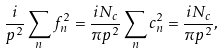<formula> <loc_0><loc_0><loc_500><loc_500>\frac { i } { p ^ { 2 } } \sum _ { n } f _ { n } ^ { 2 } = \frac { i N _ { c } } { \pi p ^ { 2 } } \sum _ { n } c _ { n } ^ { 2 } = \frac { i N _ { c } } { \pi p ^ { 2 } } ,</formula> 